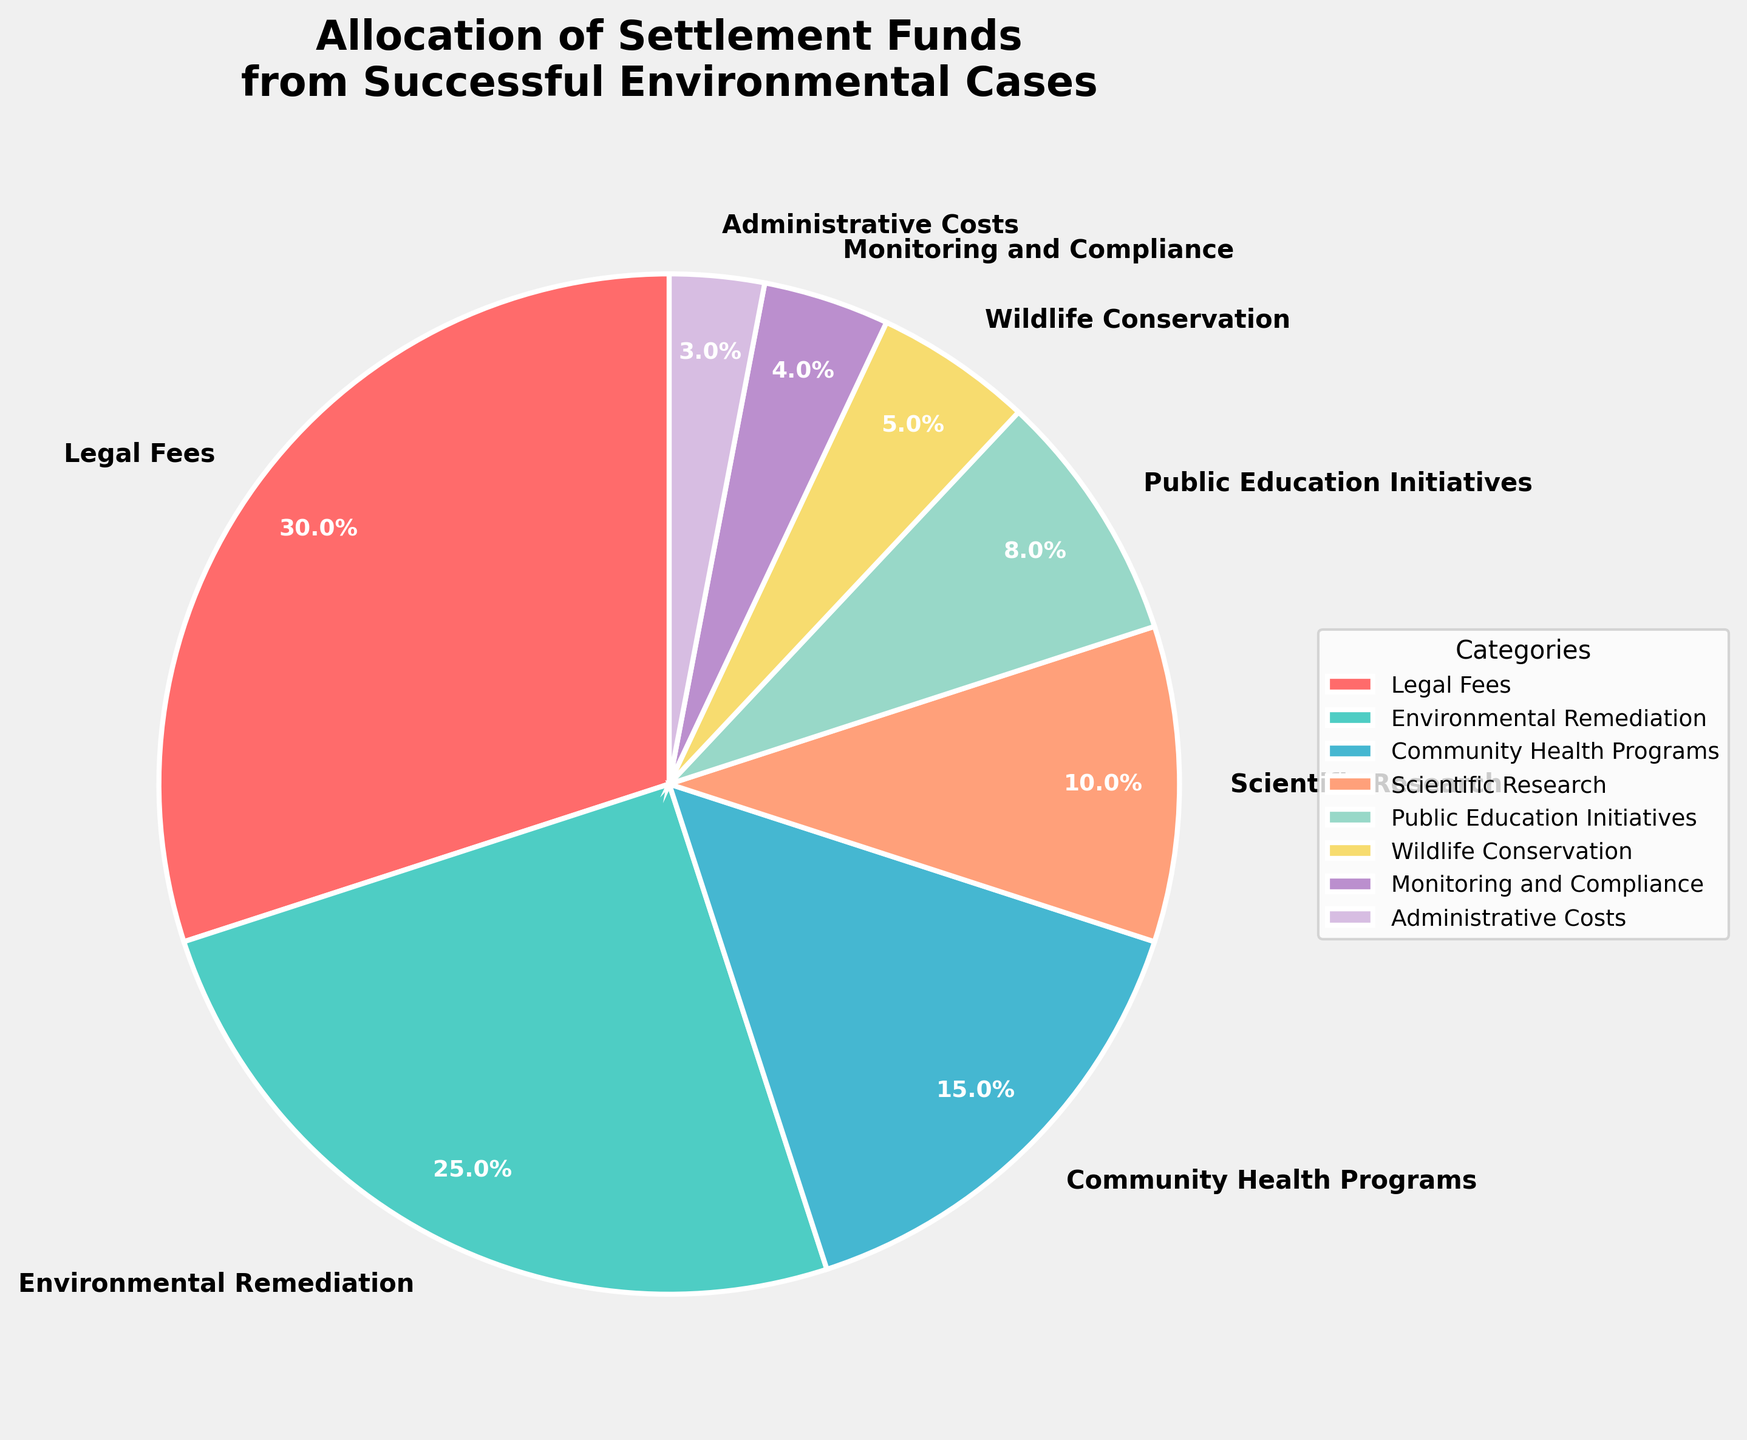What percentage of the settlement funds is allocated to Environmental Remediation? The category 'Environmental Remediation' has a label in the pie chart indicating its percentage.
Answer: 25% Which category receives the highest percentage of the settlement funds? By looking at the size of each wedge of the pie chart and the percentage labels, 'Legal Fees' has the highest percentage.
Answer: Legal Fees How much more funds do Legal Fees receive compared to Community Health Programs? 'Legal Fees' receive 30% and 'Community Health Programs' receive 15% of the funds. The difference is 30% - 15%.
Answer: 15% What is the combined percentage of funds allocated to Public Education Initiatives and Wildlife Conservation? 'Public Education Initiatives' receive 8% and 'Wildlife Conservation' receive 5%. Adding these together, 8% + 5% = 13%.
Answer: 13% Which categories receive less than 10% of the settlement funds? The labels on the pie chart show that 'Scientific Research', 'Public Education Initiatives', 'Wildlife Conservation', 'Monitoring and Compliance', and 'Administrative Costs' all receive less than 10%.
Answer: Scientific Research, Public Education Initiatives, Wildlife Conservation, Monitoring and Compliance, Administrative Costs By how many percentage points does the allocation to Community Health Programs exceed the allocation to Scientific Research? 'Community Health Programs' receive 15% and 'Scientific Research' receives 10%. The difference is 15% - 10%.
Answer: 5% Which category allocated the least funds and what is its percentage? The smallest wedge in the pie chart corresponds to 'Administrative Costs'.
Answer: Administrative Costs, 3% What is the total percentage of funds allocated to Wildlife Conservation, Monitoring and Compliance, and Administrative Costs? Adding the percentages together: 5% (Wildlife Conservation) + 4% (Monitoring and Compliance) + 3% (Administrative Costs) = 12%.
Answer: 12% If 'Community Health Programs' received twice its current allocation, what percentage of the total would it then hold? 'Community Health Programs' currently receive 15%. Doubling this percentage: 15% × 2 = 30%.
Answer: 30% Compare the allocations between Environmental Remediation and Monitoring and Compliance. How many times greater is the allocation to Environmental Remediation? 'Environmental Remediation' gets 25% and 'Monitoring and Compliance' receives 4%. To find how many times greater, divide 25% by 4%: 25 / 4 = 6.25 times.
Answer: 6.25 times 